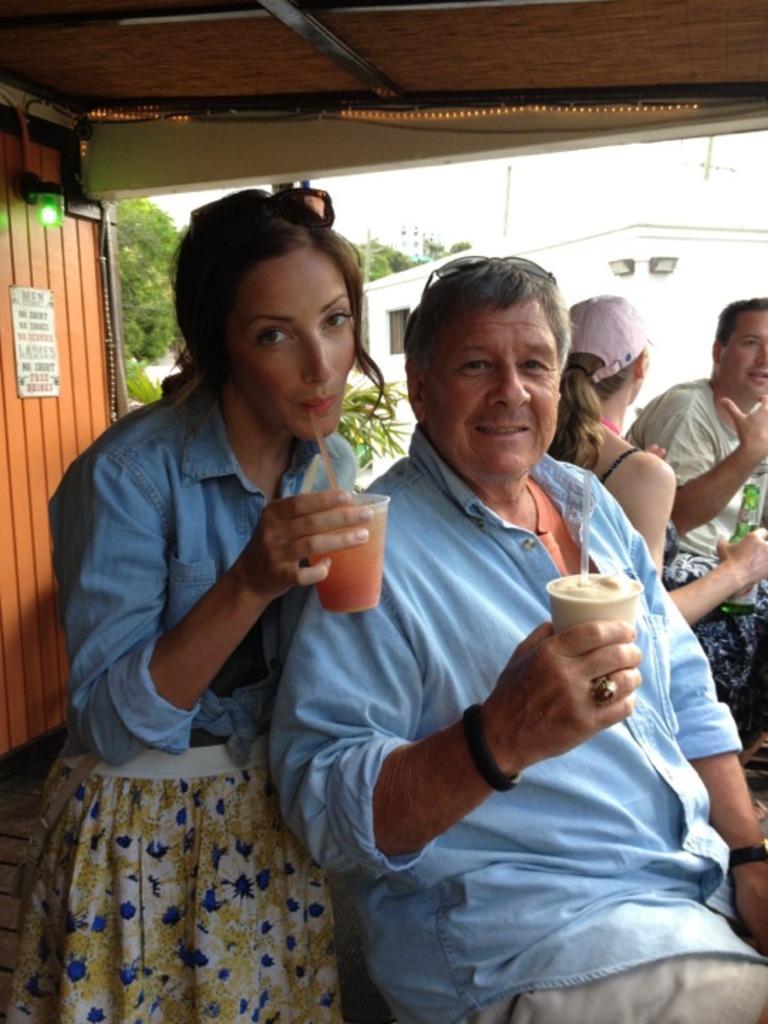How would you summarize this image in a sentence or two? In this picture we can see four persons, two persons in the front are holding glasses, on the left side there is a light and a board, in the background we can see trees and a house. 